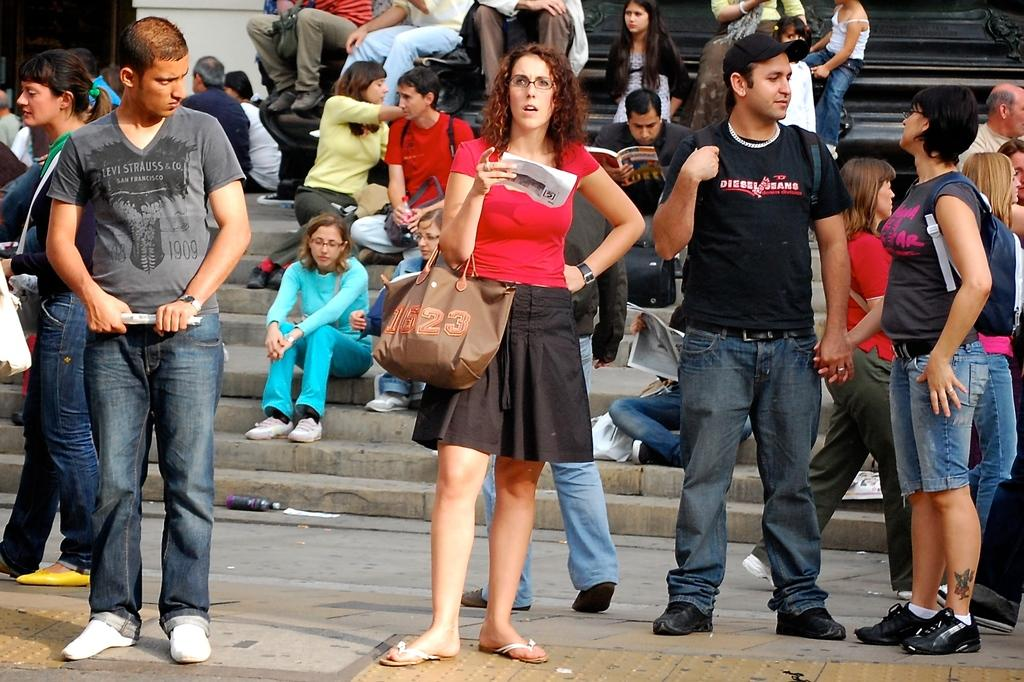What are the people in the image doing? There are people standing on the floor and sitting on the stairs in the image. Can you describe the seating arrangement in the image? In addition to the people sitting on the stairs, there are people sitting on a bench in the background. What type of hole can be seen in the image? There is no hole present in the image. Can you describe the mist in the image? There is no mist present in the image. 